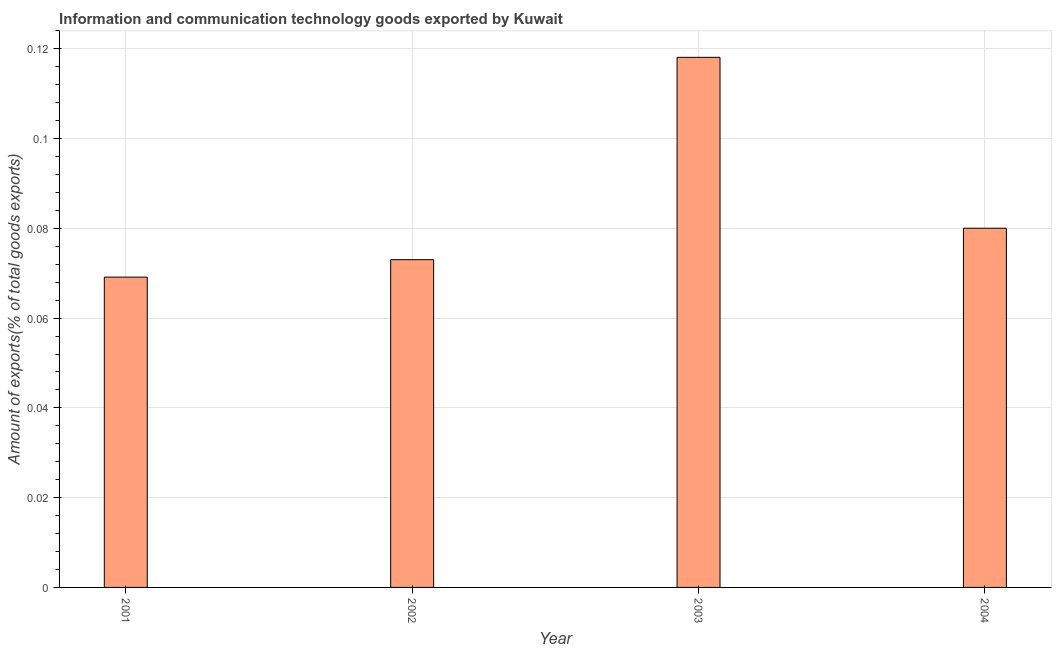Does the graph contain any zero values?
Your response must be concise. No. Does the graph contain grids?
Your response must be concise. Yes. What is the title of the graph?
Your response must be concise. Information and communication technology goods exported by Kuwait. What is the label or title of the X-axis?
Offer a very short reply. Year. What is the label or title of the Y-axis?
Keep it short and to the point. Amount of exports(% of total goods exports). What is the amount of ict goods exports in 2002?
Your response must be concise. 0.07. Across all years, what is the maximum amount of ict goods exports?
Your answer should be very brief. 0.12. Across all years, what is the minimum amount of ict goods exports?
Provide a short and direct response. 0.07. In which year was the amount of ict goods exports minimum?
Offer a very short reply. 2001. What is the sum of the amount of ict goods exports?
Provide a succinct answer. 0.34. What is the difference between the amount of ict goods exports in 2001 and 2003?
Ensure brevity in your answer.  -0.05. What is the average amount of ict goods exports per year?
Offer a very short reply. 0.09. What is the median amount of ict goods exports?
Keep it short and to the point. 0.08. Do a majority of the years between 2001 and 2004 (inclusive) have amount of ict goods exports greater than 0.112 %?
Your answer should be very brief. No. What is the ratio of the amount of ict goods exports in 2001 to that in 2004?
Offer a very short reply. 0.86. Is the amount of ict goods exports in 2002 less than that in 2004?
Your answer should be compact. Yes. What is the difference between the highest and the second highest amount of ict goods exports?
Make the answer very short. 0.04. How many bars are there?
Make the answer very short. 4. Are all the bars in the graph horizontal?
Provide a short and direct response. No. How many years are there in the graph?
Your answer should be very brief. 4. Are the values on the major ticks of Y-axis written in scientific E-notation?
Keep it short and to the point. No. What is the Amount of exports(% of total goods exports) of 2001?
Ensure brevity in your answer.  0.07. What is the Amount of exports(% of total goods exports) in 2002?
Ensure brevity in your answer.  0.07. What is the Amount of exports(% of total goods exports) in 2003?
Your answer should be compact. 0.12. What is the Amount of exports(% of total goods exports) of 2004?
Provide a succinct answer. 0.08. What is the difference between the Amount of exports(% of total goods exports) in 2001 and 2002?
Give a very brief answer. -0. What is the difference between the Amount of exports(% of total goods exports) in 2001 and 2003?
Ensure brevity in your answer.  -0.05. What is the difference between the Amount of exports(% of total goods exports) in 2001 and 2004?
Your response must be concise. -0.01. What is the difference between the Amount of exports(% of total goods exports) in 2002 and 2003?
Your answer should be compact. -0.05. What is the difference between the Amount of exports(% of total goods exports) in 2002 and 2004?
Offer a very short reply. -0.01. What is the difference between the Amount of exports(% of total goods exports) in 2003 and 2004?
Your answer should be compact. 0.04. What is the ratio of the Amount of exports(% of total goods exports) in 2001 to that in 2002?
Your answer should be compact. 0.95. What is the ratio of the Amount of exports(% of total goods exports) in 2001 to that in 2003?
Provide a short and direct response. 0.58. What is the ratio of the Amount of exports(% of total goods exports) in 2001 to that in 2004?
Ensure brevity in your answer.  0.86. What is the ratio of the Amount of exports(% of total goods exports) in 2002 to that in 2003?
Provide a succinct answer. 0.62. What is the ratio of the Amount of exports(% of total goods exports) in 2002 to that in 2004?
Offer a very short reply. 0.91. What is the ratio of the Amount of exports(% of total goods exports) in 2003 to that in 2004?
Your answer should be very brief. 1.48. 